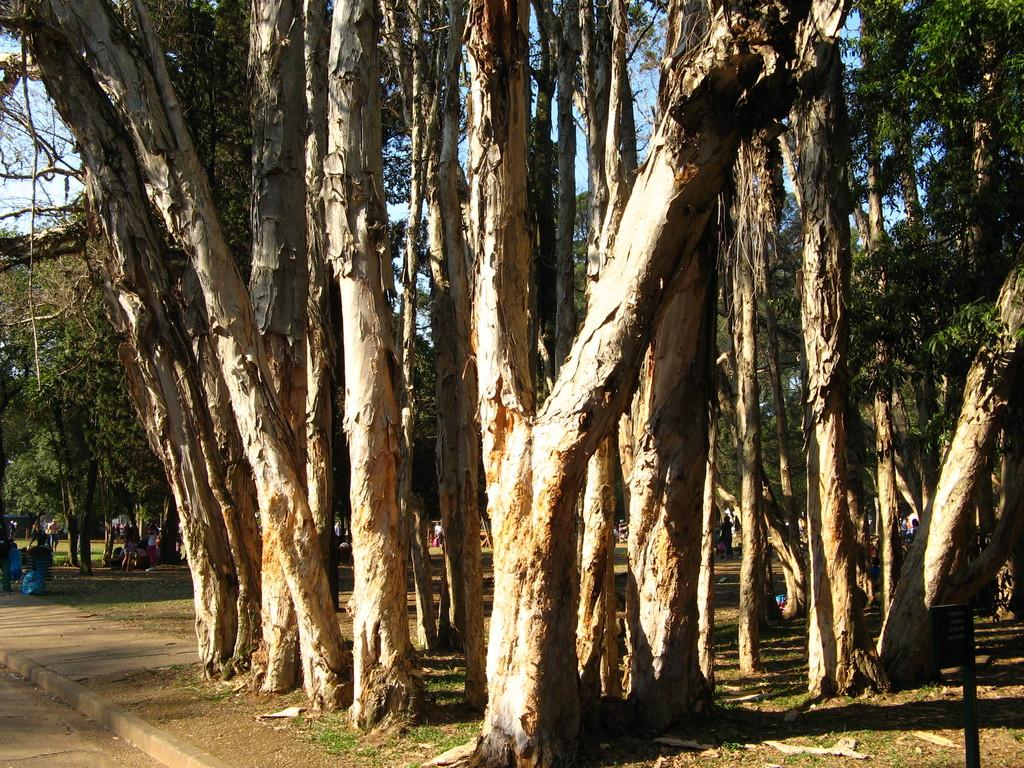What is the primary setting of the image? There are persons standing on the ground in the image. What else can be seen in the image besides the persons? There are objects and tree trunks in the image. Can you describe the vegetation in the image? There are trees in the image. What is visible in the background of the image? The sky is visible in the image. What type of bread can be seen floating in the sky in the image? There is no bread present in the image, and bread cannot float in the sky. 